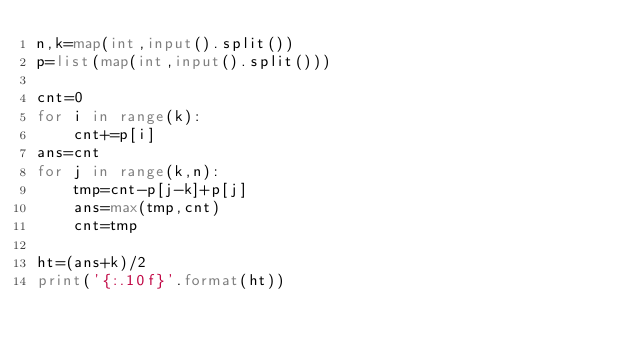<code> <loc_0><loc_0><loc_500><loc_500><_Python_>n,k=map(int,input().split())
p=list(map(int,input().split()))

cnt=0
for i in range(k):
    cnt+=p[i]
ans=cnt
for j in range(k,n):
    tmp=cnt-p[j-k]+p[j]
    ans=max(tmp,cnt)
    cnt=tmp

ht=(ans+k)/2
print('{:.10f}'.format(ht))</code> 